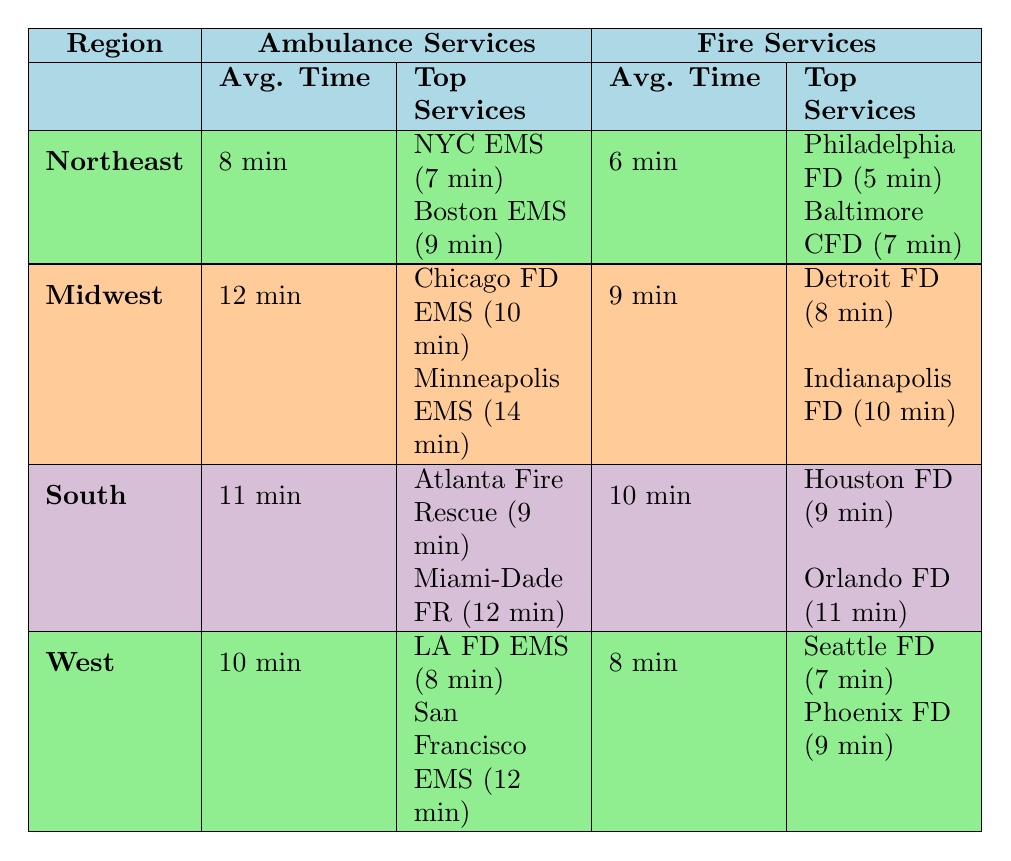What is the average response time for ambulance services in the Northeast? The table states that the average response time for ambulance services in the Northeast is 8 minutes.
Answer: 8 minutes Which service has the fastest response time in the Midwest for ambulance services? In the Midwest, the fastest response time for ambulance services is by the Chicago Fire Department EMS, which is 10 minutes.
Answer: Chicago Fire Department EMS (10 minutes) Are the average response times for fire services in the South greater than 9 minutes? The average response time for fire services in the South is 10 minutes, which is greater than 9 minutes.
Answer: Yes What is the difference between the average response times for ambulance services in the Northeast and the South? The average response time for ambulance services in the Northeast is 8 minutes, and for the South, it is 11 minutes. The difference is 11 - 8 = 3 minutes.
Answer: 3 minutes Which region has the quickest average response time for fire services? The quickest average response time for fire services is in the West, with an average of 8 minutes.
Answer: West (8 minutes) Is it true that Philadelphia Fire Department has a better response time than the Indianapolis Fire Department? The Philadelphia Fire Department has a response time of 5 minutes, while the Indianapolis Fire Department has a response time of 10 minutes. This makes the statement true.
Answer: Yes What is the average response time for fire services in the Midwest? The table indicates that the average response time for fire services in the Midwest is 9 minutes, as noted in the respective row of the table.
Answer: 9 minutes What is the combined average response time for ambulance services in the Northeast and Midwest? The average response time for ambulance services in the Northeast is 8 minutes, and in the Midwest, it is 12 minutes. The combined average is (8 + 12) / 2 = 10 minutes.
Answer: 10 minutes Which region shows the highest average response time for ambulance services? The highest average response time for ambulance services is in the Midwest, which has an average of 12 minutes.
Answer: Midwest (12 minutes) 